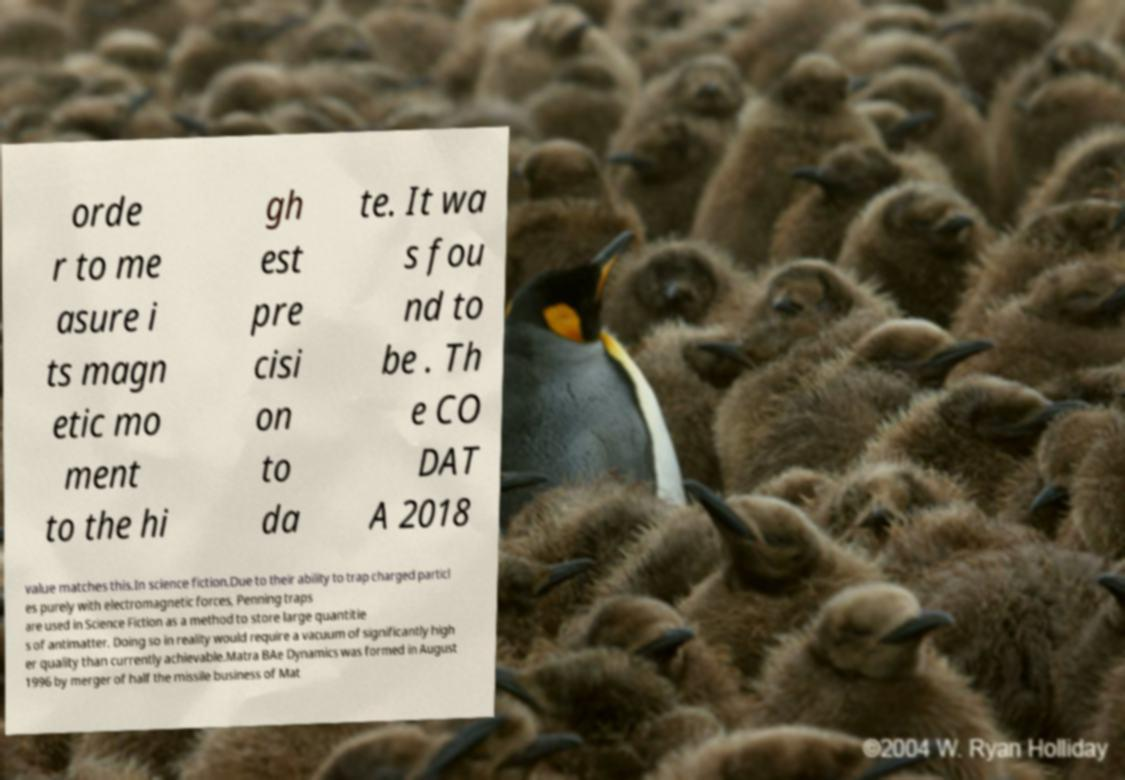Please identify and transcribe the text found in this image. orde r to me asure i ts magn etic mo ment to the hi gh est pre cisi on to da te. It wa s fou nd to be . Th e CO DAT A 2018 value matches this.In science fiction.Due to their ability to trap charged particl es purely with electromagnetic forces, Penning traps are used in Science Fiction as a method to store large quantitie s of antimatter. Doing so in reality would require a vacuum of significantly high er quality than currently achievable.Matra BAe Dynamics was formed in August 1996 by merger of half the missile business of Mat 